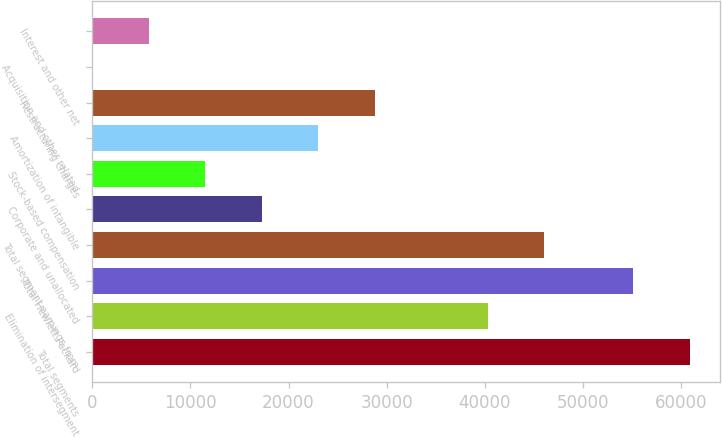<chart> <loc_0><loc_0><loc_500><loc_500><bar_chart><fcel>Total segments<fcel>Elimination of intersegment<fcel>Total Hewlett Packard<fcel>Total segment earnings from<fcel>Corporate and unallocated<fcel>Stock-based compensation<fcel>Amortization of intangible<fcel>Restructuring charges<fcel>Acquisition and other related<fcel>Interest and other net<nl><fcel>60877.9<fcel>40295.3<fcel>55123<fcel>46050.2<fcel>17275.7<fcel>11520.8<fcel>23030.6<fcel>28785.5<fcel>11<fcel>5765.9<nl></chart> 